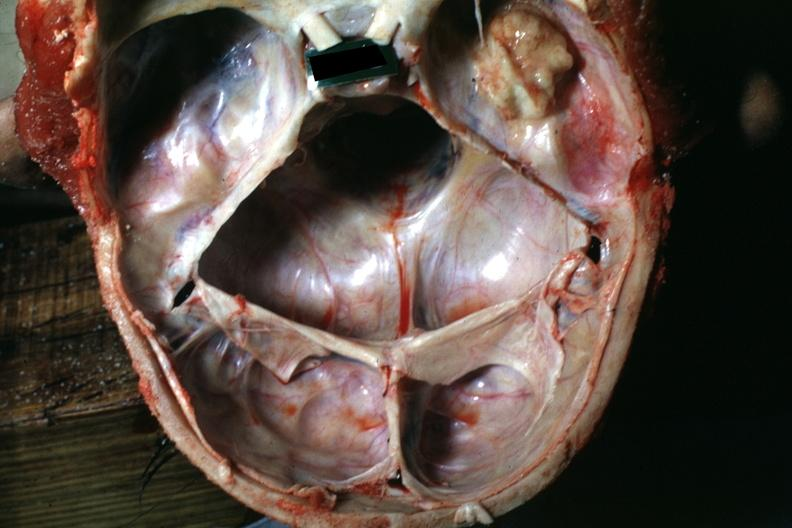what does this image show?
Answer the question using a single word or phrase. Large nodular osteoma in right temporal fossa 